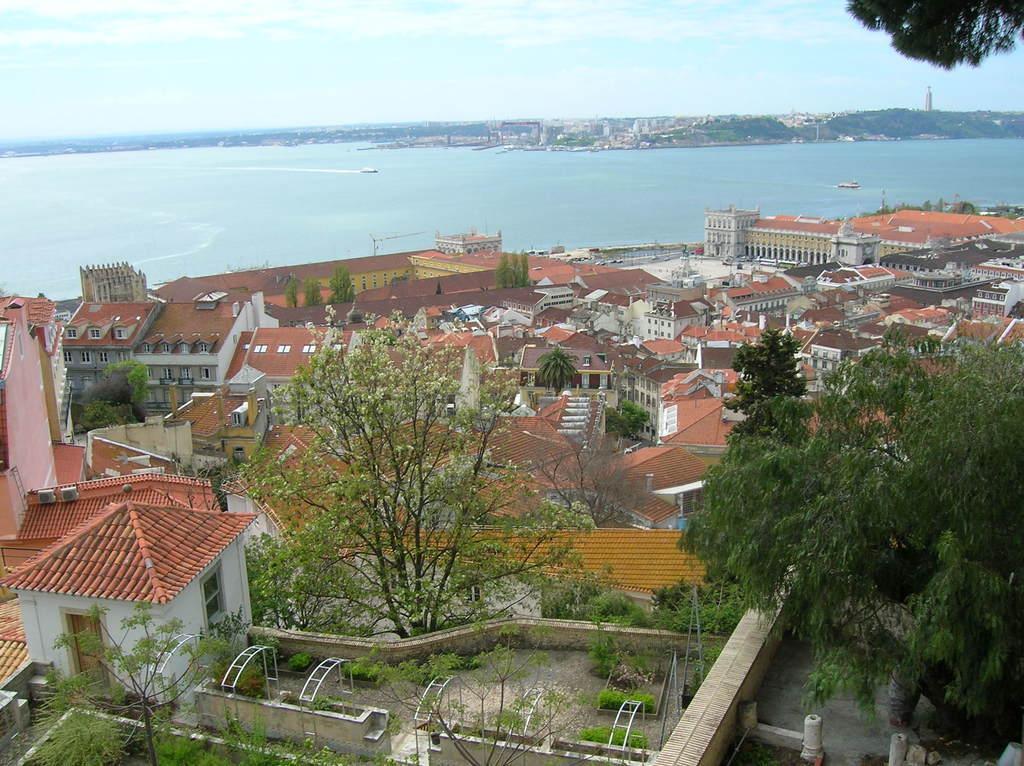Can you describe this image briefly? In this picture we can see the top view of a city with many houses, trees & sea. The sky is blue. 